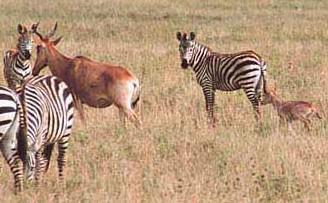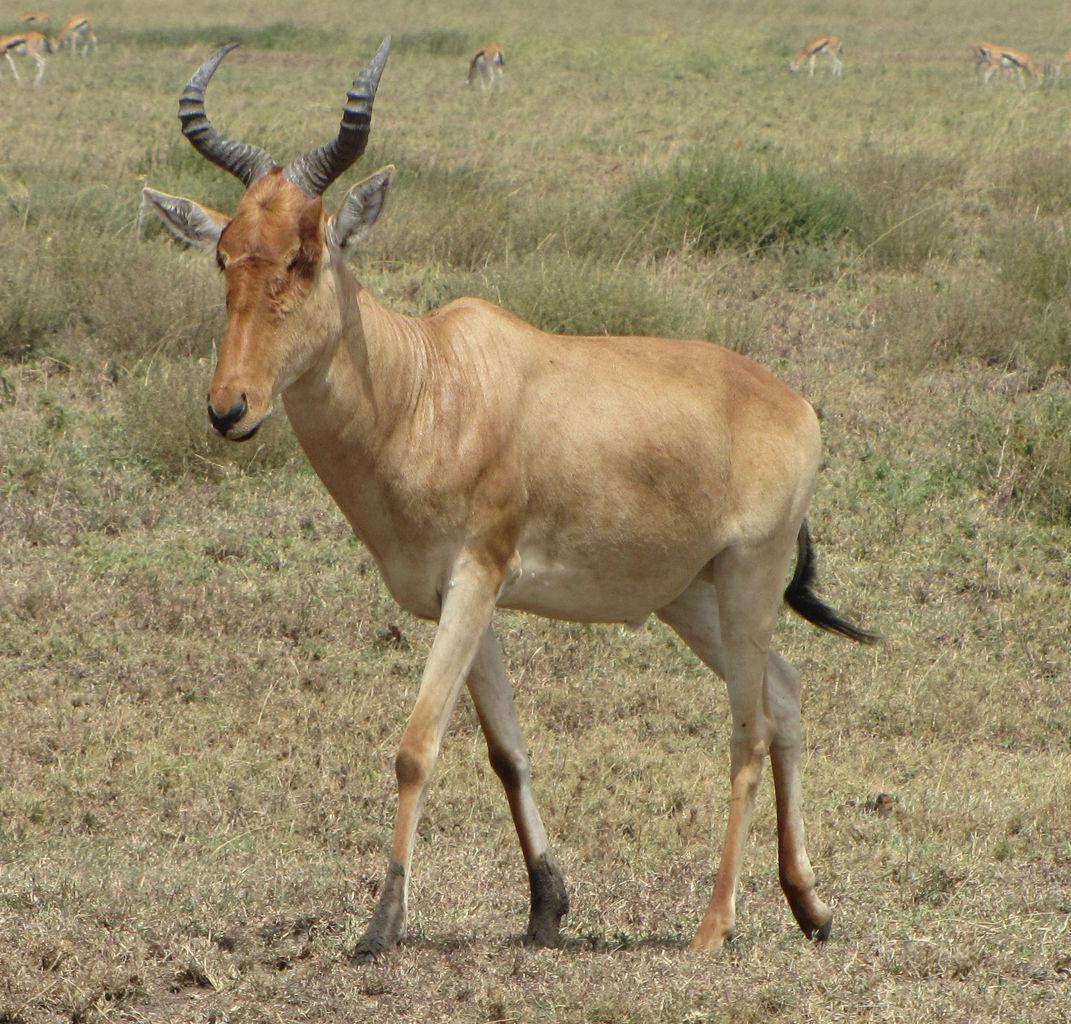The first image is the image on the left, the second image is the image on the right. Assess this claim about the two images: "There are two different types of animals in one of the pictures.". Correct or not? Answer yes or no. Yes. 